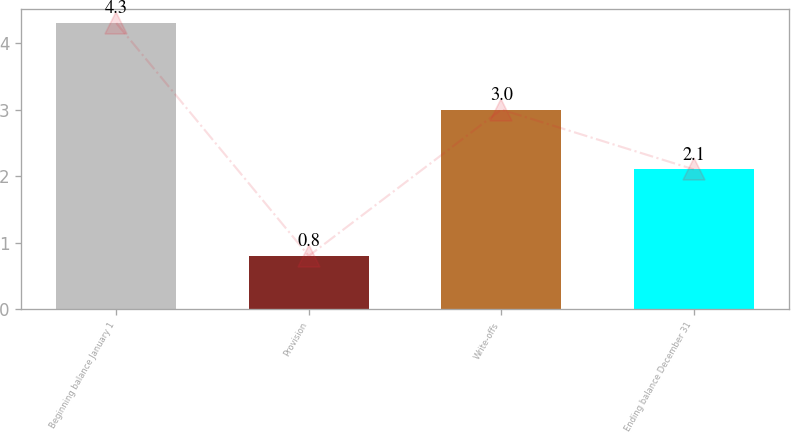Convert chart to OTSL. <chart><loc_0><loc_0><loc_500><loc_500><bar_chart><fcel>Beginning balance January 1<fcel>Provision<fcel>Write-offs<fcel>Ending balance December 31<nl><fcel>4.3<fcel>0.8<fcel>3<fcel>2.1<nl></chart> 